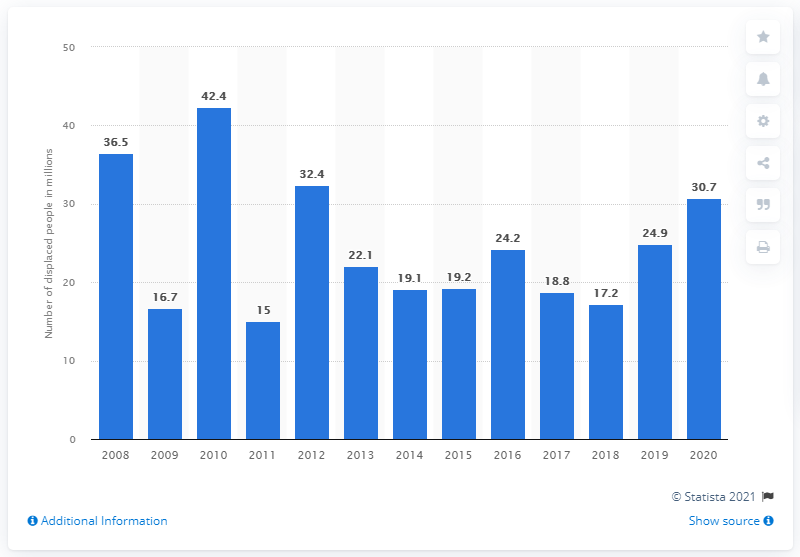Highlight a few significant elements in this photo. In 2010, the highest number of people forced to flee their homes was 42.4 million. In 2020, it is estimated that 30.7 million people were forced to flee their homes due to various reasons such as conflict, persecution, and natural disasters. The highest number of people forced to flee their homes in 2010 was approximately 42.4 million. 